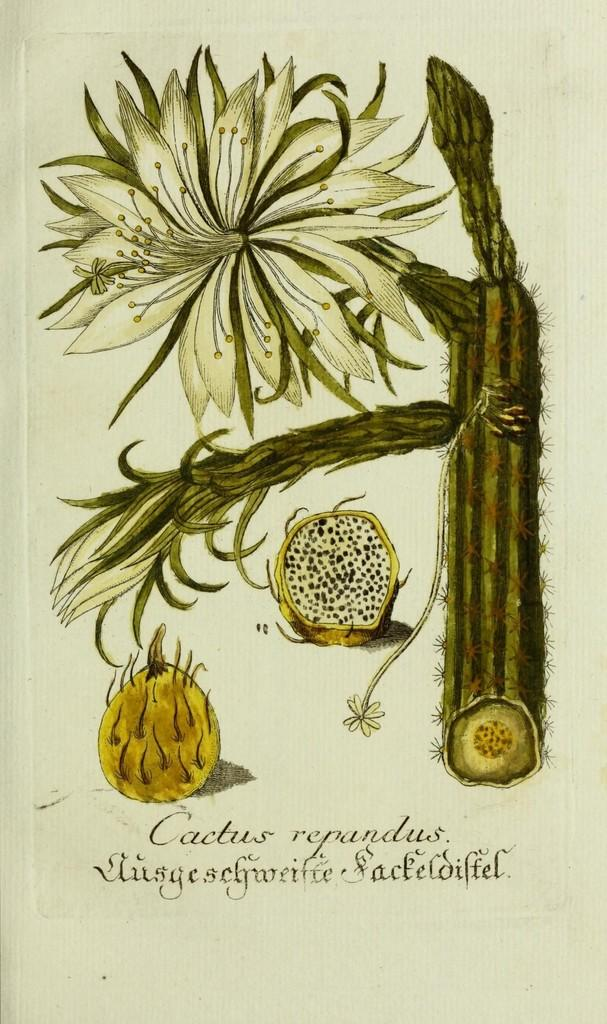What is present in the image that contains information or visuals? There is a poster in the image. What can be found on the poster besides images? The poster contains text. What type of visuals are included on the poster? The poster contains printed pictures. What type of wine is being served at the band's performance in the image? There is no band or wine present in the image; it only features a poster with text and printed pictures. 